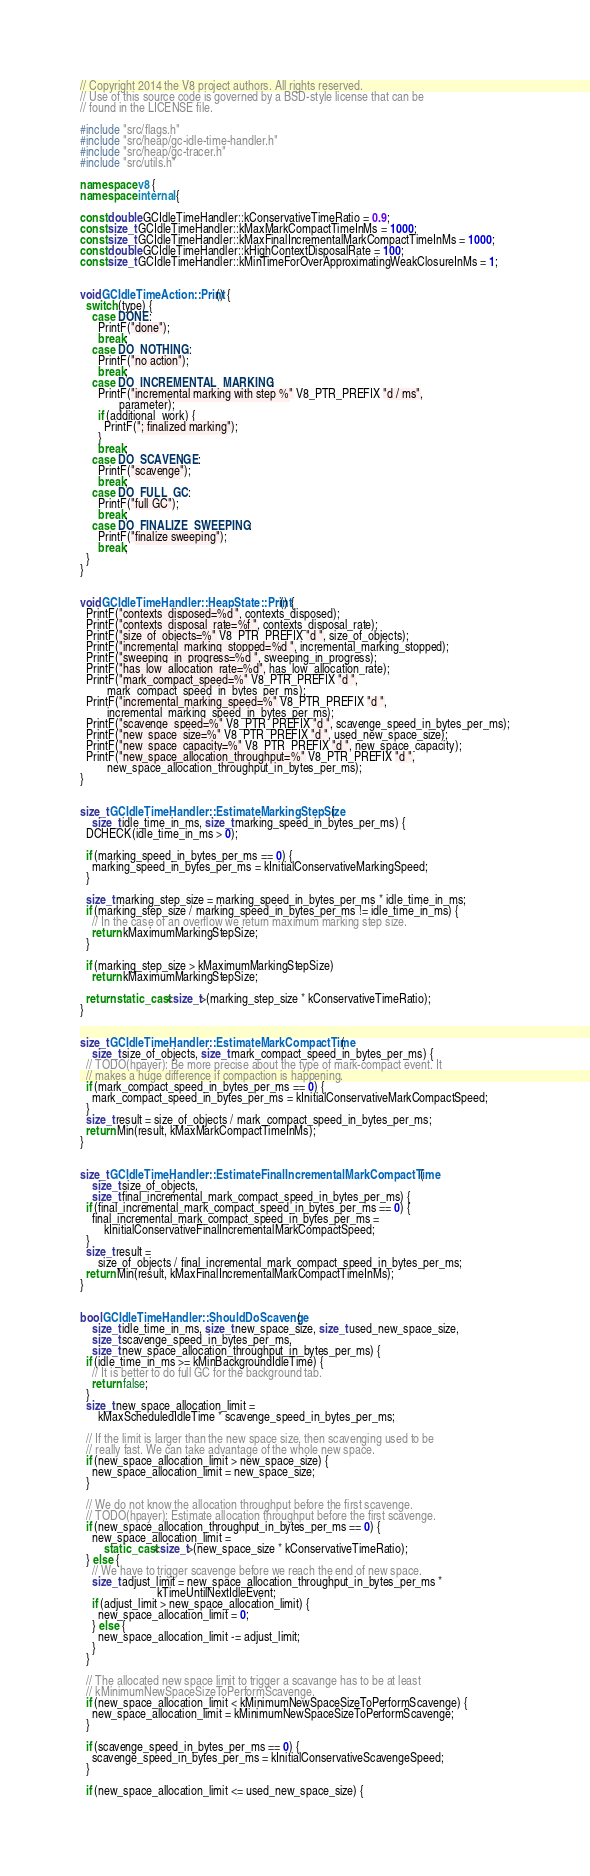Convert code to text. <code><loc_0><loc_0><loc_500><loc_500><_C++_>// Copyright 2014 the V8 project authors. All rights reserved.
// Use of this source code is governed by a BSD-style license that can be
// found in the LICENSE file.

#include "src/flags.h"
#include "src/heap/gc-idle-time-handler.h"
#include "src/heap/gc-tracer.h"
#include "src/utils.h"

namespace v8 {
namespace internal {

const double GCIdleTimeHandler::kConservativeTimeRatio = 0.9;
const size_t GCIdleTimeHandler::kMaxMarkCompactTimeInMs = 1000;
const size_t GCIdleTimeHandler::kMaxFinalIncrementalMarkCompactTimeInMs = 1000;
const double GCIdleTimeHandler::kHighContextDisposalRate = 100;
const size_t GCIdleTimeHandler::kMinTimeForOverApproximatingWeakClosureInMs = 1;


void GCIdleTimeAction::Print() {
  switch (type) {
    case DONE:
      PrintF("done");
      break;
    case DO_NOTHING:
      PrintF("no action");
      break;
    case DO_INCREMENTAL_MARKING:
      PrintF("incremental marking with step %" V8_PTR_PREFIX "d / ms",
             parameter);
      if (additional_work) {
        PrintF("; finalized marking");
      }
      break;
    case DO_SCAVENGE:
      PrintF("scavenge");
      break;
    case DO_FULL_GC:
      PrintF("full GC");
      break;
    case DO_FINALIZE_SWEEPING:
      PrintF("finalize sweeping");
      break;
  }
}


void GCIdleTimeHandler::HeapState::Print() {
  PrintF("contexts_disposed=%d ", contexts_disposed);
  PrintF("contexts_disposal_rate=%f ", contexts_disposal_rate);
  PrintF("size_of_objects=%" V8_PTR_PREFIX "d ", size_of_objects);
  PrintF("incremental_marking_stopped=%d ", incremental_marking_stopped);
  PrintF("sweeping_in_progress=%d ", sweeping_in_progress);
  PrintF("has_low_allocation_rate=%d", has_low_allocation_rate);
  PrintF("mark_compact_speed=%" V8_PTR_PREFIX "d ",
         mark_compact_speed_in_bytes_per_ms);
  PrintF("incremental_marking_speed=%" V8_PTR_PREFIX "d ",
         incremental_marking_speed_in_bytes_per_ms);
  PrintF("scavenge_speed=%" V8_PTR_PREFIX "d ", scavenge_speed_in_bytes_per_ms);
  PrintF("new_space_size=%" V8_PTR_PREFIX "d ", used_new_space_size);
  PrintF("new_space_capacity=%" V8_PTR_PREFIX "d ", new_space_capacity);
  PrintF("new_space_allocation_throughput=%" V8_PTR_PREFIX "d ",
         new_space_allocation_throughput_in_bytes_per_ms);
}


size_t GCIdleTimeHandler::EstimateMarkingStepSize(
    size_t idle_time_in_ms, size_t marking_speed_in_bytes_per_ms) {
  DCHECK(idle_time_in_ms > 0);

  if (marking_speed_in_bytes_per_ms == 0) {
    marking_speed_in_bytes_per_ms = kInitialConservativeMarkingSpeed;
  }

  size_t marking_step_size = marking_speed_in_bytes_per_ms * idle_time_in_ms;
  if (marking_step_size / marking_speed_in_bytes_per_ms != idle_time_in_ms) {
    // In the case of an overflow we return maximum marking step size.
    return kMaximumMarkingStepSize;
  }

  if (marking_step_size > kMaximumMarkingStepSize)
    return kMaximumMarkingStepSize;

  return static_cast<size_t>(marking_step_size * kConservativeTimeRatio);
}


size_t GCIdleTimeHandler::EstimateMarkCompactTime(
    size_t size_of_objects, size_t mark_compact_speed_in_bytes_per_ms) {
  // TODO(hpayer): Be more precise about the type of mark-compact event. It
  // makes a huge difference if compaction is happening.
  if (mark_compact_speed_in_bytes_per_ms == 0) {
    mark_compact_speed_in_bytes_per_ms = kInitialConservativeMarkCompactSpeed;
  }
  size_t result = size_of_objects / mark_compact_speed_in_bytes_per_ms;
  return Min(result, kMaxMarkCompactTimeInMs);
}


size_t GCIdleTimeHandler::EstimateFinalIncrementalMarkCompactTime(
    size_t size_of_objects,
    size_t final_incremental_mark_compact_speed_in_bytes_per_ms) {
  if (final_incremental_mark_compact_speed_in_bytes_per_ms == 0) {
    final_incremental_mark_compact_speed_in_bytes_per_ms =
        kInitialConservativeFinalIncrementalMarkCompactSpeed;
  }
  size_t result =
      size_of_objects / final_incremental_mark_compact_speed_in_bytes_per_ms;
  return Min(result, kMaxFinalIncrementalMarkCompactTimeInMs);
}


bool GCIdleTimeHandler::ShouldDoScavenge(
    size_t idle_time_in_ms, size_t new_space_size, size_t used_new_space_size,
    size_t scavenge_speed_in_bytes_per_ms,
    size_t new_space_allocation_throughput_in_bytes_per_ms) {
  if (idle_time_in_ms >= kMinBackgroundIdleTime) {
    // It is better to do full GC for the background tab.
    return false;
  }
  size_t new_space_allocation_limit =
      kMaxScheduledIdleTime * scavenge_speed_in_bytes_per_ms;

  // If the limit is larger than the new space size, then scavenging used to be
  // really fast. We can take advantage of the whole new space.
  if (new_space_allocation_limit > new_space_size) {
    new_space_allocation_limit = new_space_size;
  }

  // We do not know the allocation throughput before the first scavenge.
  // TODO(hpayer): Estimate allocation throughput before the first scavenge.
  if (new_space_allocation_throughput_in_bytes_per_ms == 0) {
    new_space_allocation_limit =
        static_cast<size_t>(new_space_size * kConservativeTimeRatio);
  } else {
    // We have to trigger scavenge before we reach the end of new space.
    size_t adjust_limit = new_space_allocation_throughput_in_bytes_per_ms *
                          kTimeUntilNextIdleEvent;
    if (adjust_limit > new_space_allocation_limit) {
      new_space_allocation_limit = 0;
    } else {
      new_space_allocation_limit -= adjust_limit;
    }
  }

  // The allocated new space limit to trigger a scavange has to be at least
  // kMinimumNewSpaceSizeToPerformScavenge.
  if (new_space_allocation_limit < kMinimumNewSpaceSizeToPerformScavenge) {
    new_space_allocation_limit = kMinimumNewSpaceSizeToPerformScavenge;
  }

  if (scavenge_speed_in_bytes_per_ms == 0) {
    scavenge_speed_in_bytes_per_ms = kInitialConservativeScavengeSpeed;
  }

  if (new_space_allocation_limit <= used_new_space_size) {</code> 